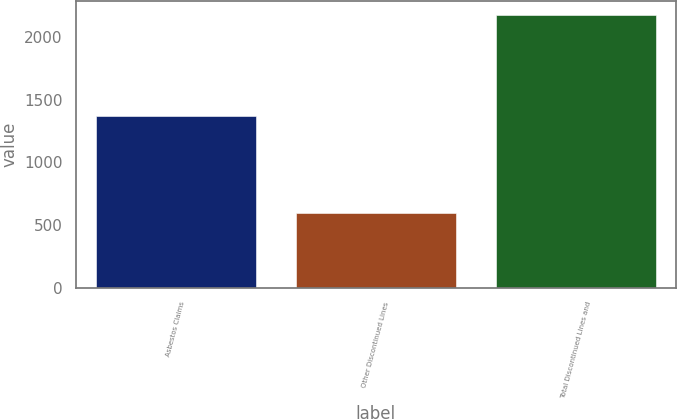Convert chart. <chart><loc_0><loc_0><loc_500><loc_500><bar_chart><fcel>Asbestos Claims<fcel>Other Discontinued Lines<fcel>Total Discontinued Lines and<nl><fcel>1373<fcel>599<fcel>2177<nl></chart> 